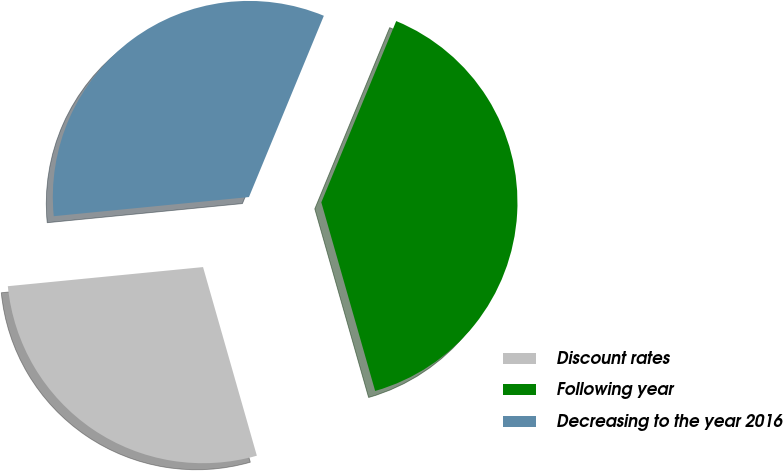Convert chart. <chart><loc_0><loc_0><loc_500><loc_500><pie_chart><fcel>Discount rates<fcel>Following year<fcel>Decreasing to the year 2016<nl><fcel>27.87%<fcel>39.34%<fcel>32.79%<nl></chart> 